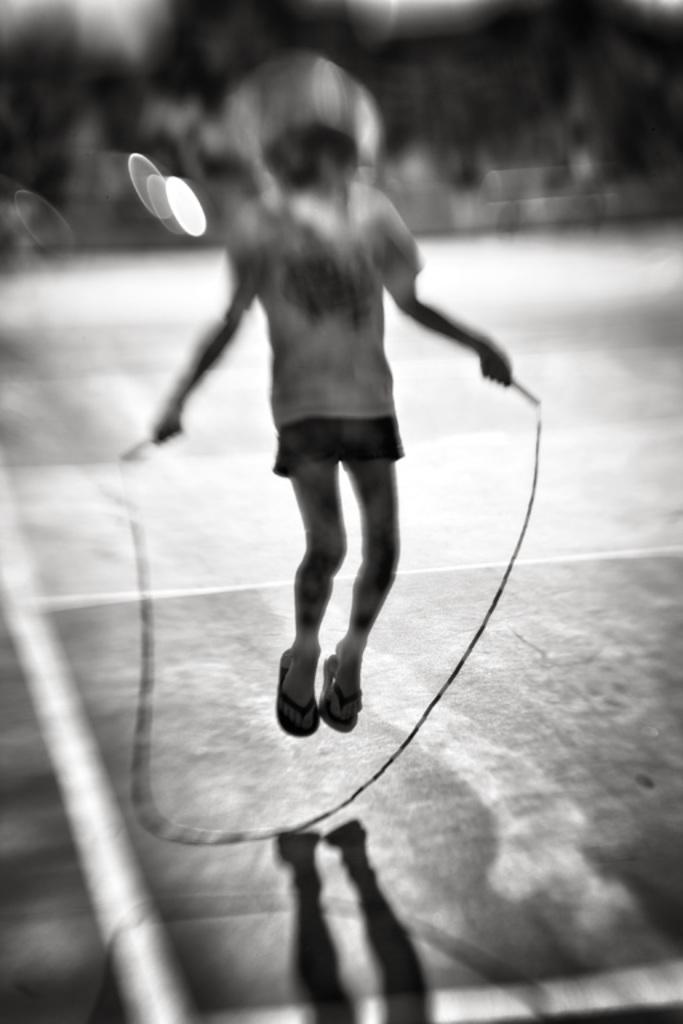Describe this image in one or two sentences. This is a black and white image. In the center of the image we can see person slipping on the ground. 